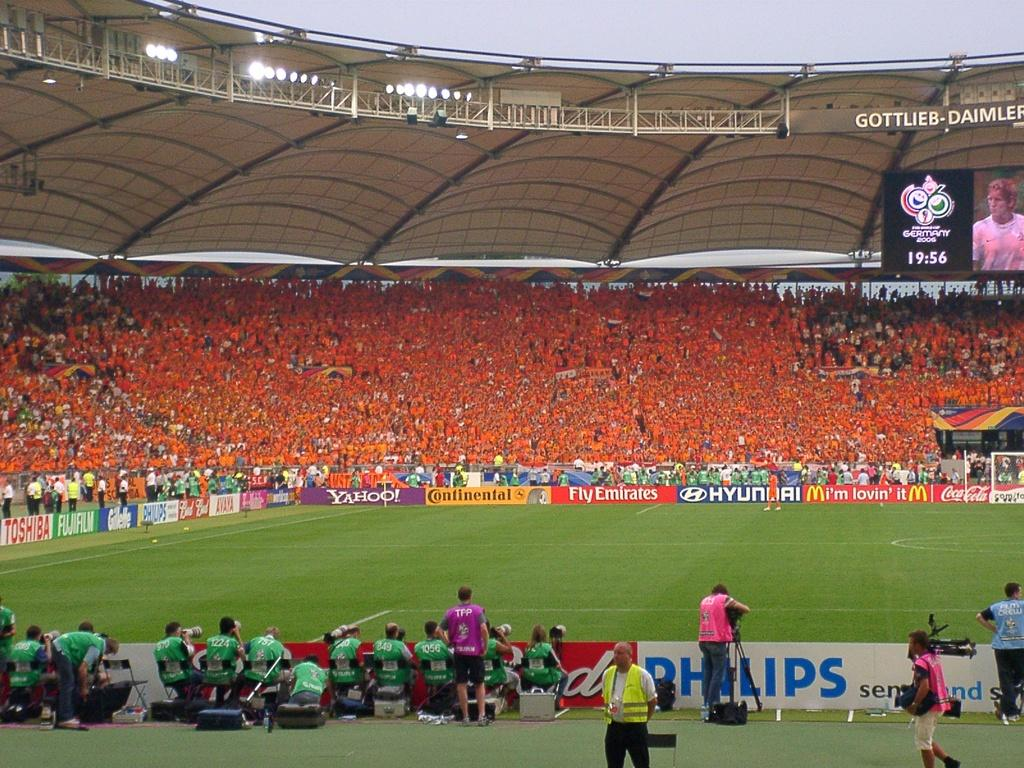<image>
Relay a brief, clear account of the picture shown. the word philips is on the sign next to the field 